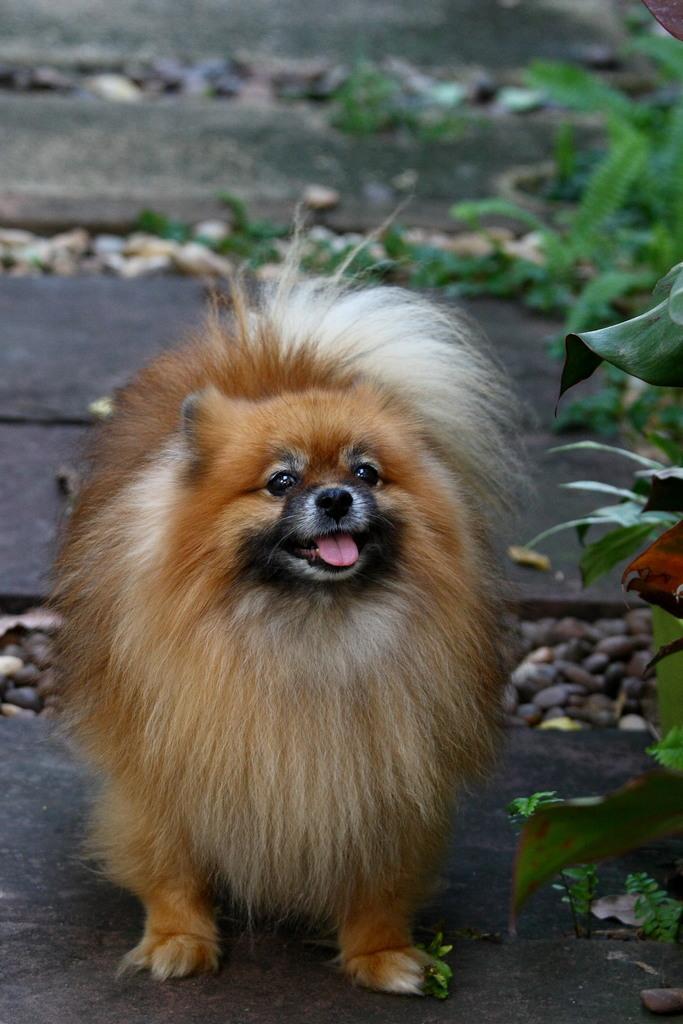In one or two sentences, can you explain what this image depicts? In this image I can see a dog. I can see few plants and leafs on the ground. 